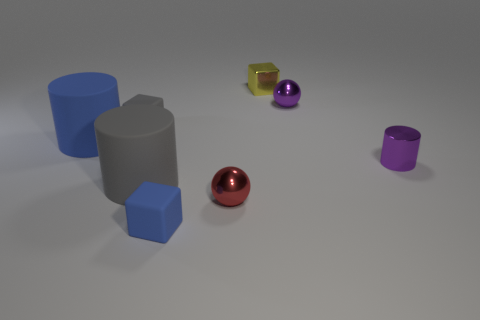Is there a blue rubber cylinder that has the same size as the gray rubber cylinder?
Provide a short and direct response. Yes. Does the matte cube that is behind the red metal thing have the same size as the large gray object?
Make the answer very short. No. What shape is the object that is both in front of the small gray thing and to the left of the large gray object?
Keep it short and to the point. Cylinder. Is the number of cylinders left of the metal cube greater than the number of tiny yellow shiny cylinders?
Your response must be concise. Yes. There is a purple cylinder that is the same material as the tiny yellow block; what size is it?
Offer a terse response. Small. How many small balls have the same color as the small cylinder?
Ensure brevity in your answer.  1. There is a tiny shiny sphere that is in front of the tiny gray matte thing; does it have the same color as the tiny metallic cylinder?
Ensure brevity in your answer.  No. Is the number of blue objects to the right of the tiny red shiny object the same as the number of purple metal spheres that are in front of the shiny cylinder?
Provide a succinct answer. Yes. The metallic sphere that is behind the red sphere is what color?
Offer a very short reply. Purple. Is the number of small purple cylinders that are behind the tiny gray cube the same as the number of small yellow shiny cubes?
Offer a very short reply. No. 